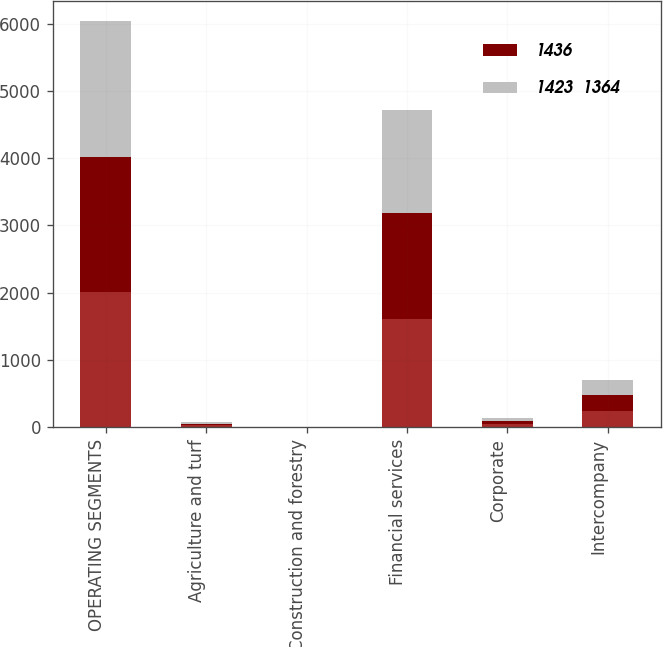Convert chart to OTSL. <chart><loc_0><loc_0><loc_500><loc_500><stacked_bar_chart><ecel><fcel>OPERATING SEGMENTS<fcel>Agriculture and turf<fcel>Construction and forestry<fcel>Financial services<fcel>Corporate<fcel>Intercompany<nl><fcel>nan<fcel>2012<fcel>29<fcel>2<fcel>1610<fcel>43<fcel>248<nl><fcel>1436<fcel>2011<fcel>23<fcel>3<fcel>1581<fcel>47<fcel>231<nl><fcel>1423  1364<fcel>2010<fcel>20<fcel>3<fcel>1528<fcel>42<fcel>229<nl></chart> 